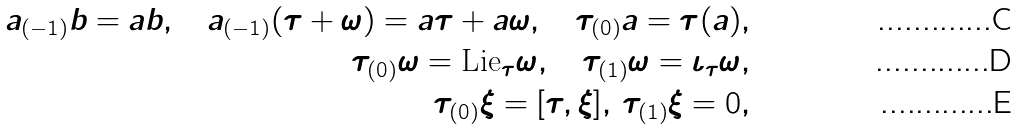<formula> <loc_0><loc_0><loc_500><loc_500>a _ { ( - 1 ) } b = a b , \quad a _ { ( - 1 ) } ( \tau + \omega ) = a \tau + a \omega , \quad \tau _ { ( 0 ) } a = \tau ( a ) , \\ \tau _ { ( 0 ) } \omega = \text {Lie} _ { \tau } \omega , \quad \tau _ { ( 1 ) } \omega = \iota _ { \tau } \omega , \\ \tau _ { ( 0 ) } \xi = [ \tau , \xi ] , \, \tau _ { ( 1 ) } \xi = 0 ,</formula> 